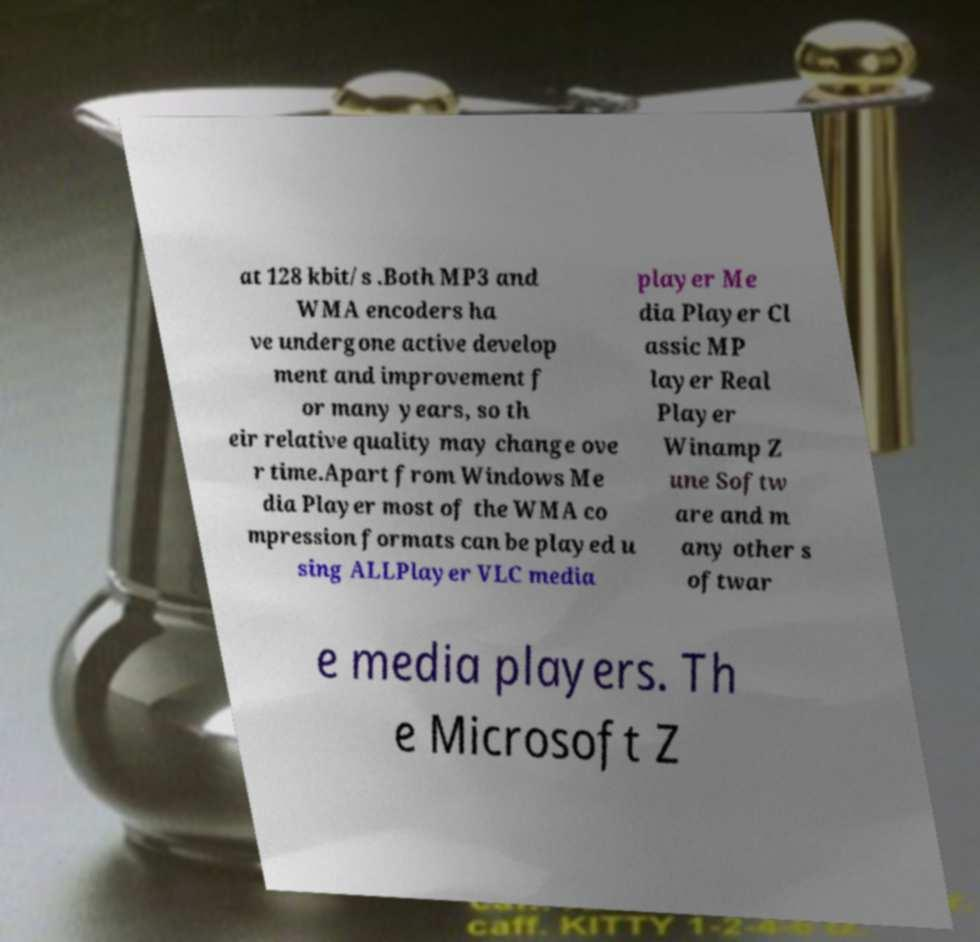I need the written content from this picture converted into text. Can you do that? at 128 kbit/s .Both MP3 and WMA encoders ha ve undergone active develop ment and improvement f or many years, so th eir relative quality may change ove r time.Apart from Windows Me dia Player most of the WMA co mpression formats can be played u sing ALLPlayer VLC media player Me dia Player Cl assic MP layer Real Player Winamp Z une Softw are and m any other s oftwar e media players. Th e Microsoft Z 